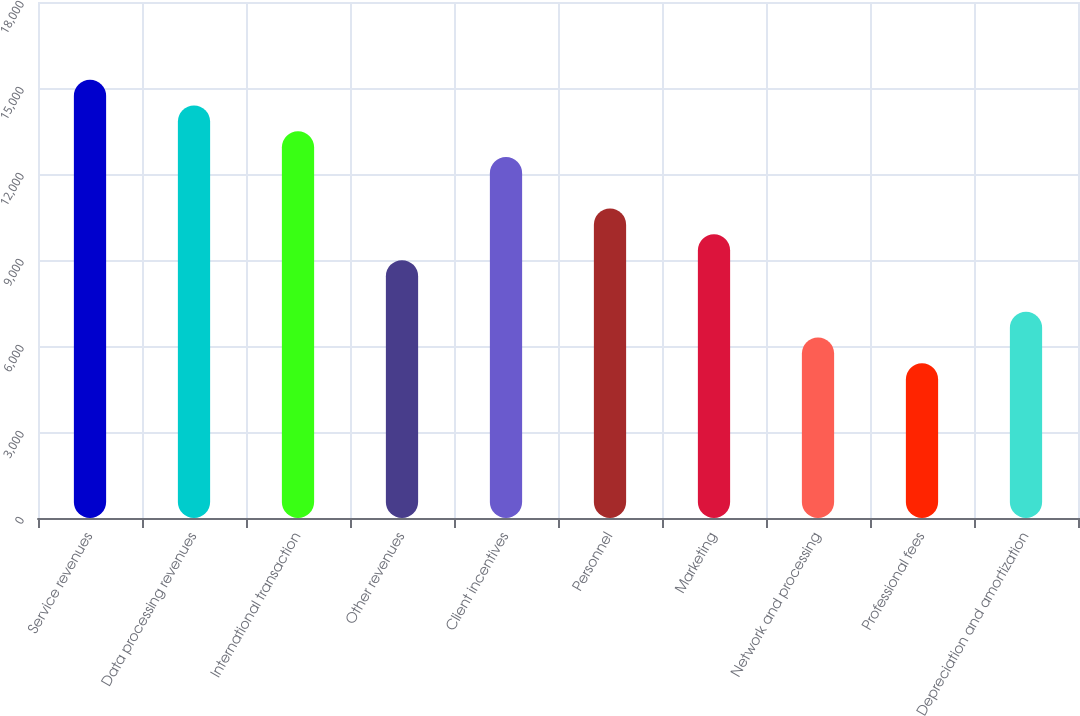Convert chart. <chart><loc_0><loc_0><loc_500><loc_500><bar_chart><fcel>Service revenues<fcel>Data processing revenues<fcel>International transaction<fcel>Other revenues<fcel>Client incentives<fcel>Personnel<fcel>Marketing<fcel>Network and processing<fcel>Professional fees<fcel>Depreciation and amortization<nl><fcel>15289.7<fcel>14390.4<fcel>13491.2<fcel>8994.98<fcel>12591.9<fcel>10793.5<fcel>9894.22<fcel>6297.26<fcel>5398.02<fcel>7196.5<nl></chart> 